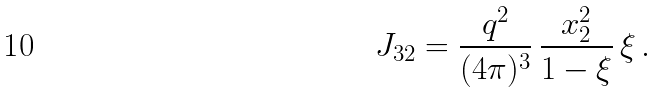Convert formula to latex. <formula><loc_0><loc_0><loc_500><loc_500>J _ { 3 2 } = \frac { q ^ { 2 } } { ( 4 \pi ) ^ { 3 } } \, \frac { x _ { 2 } ^ { 2 } } { 1 - \xi } \, \xi \, .</formula> 